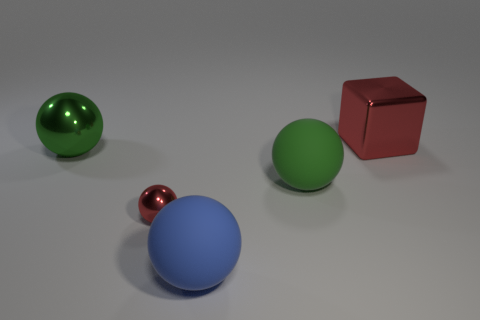There is a large green object to the right of the small object; is its shape the same as the red thing in front of the large metallic block?
Make the answer very short. Yes. Are there any large blue things that have the same material as the red ball?
Provide a short and direct response. No. The shiny cube has what color?
Ensure brevity in your answer.  Red. There is a metal thing that is right of the green rubber sphere; what size is it?
Provide a succinct answer. Large. How many metal cubes are the same color as the small shiny object?
Provide a succinct answer. 1. There is a metallic ball that is in front of the green shiny thing; are there any small red shiny things that are on the left side of it?
Your answer should be very brief. No. There is a big metal object that is on the left side of the large red block; is its color the same as the metallic ball that is right of the large green metallic thing?
Offer a very short reply. No. There is a cube that is the same size as the green rubber sphere; what color is it?
Give a very brief answer. Red. Is the number of big blue balls that are in front of the small red shiny object the same as the number of red shiny blocks to the left of the big cube?
Offer a very short reply. No. The green sphere left of the metallic sphere in front of the large green rubber object is made of what material?
Offer a terse response. Metal. 